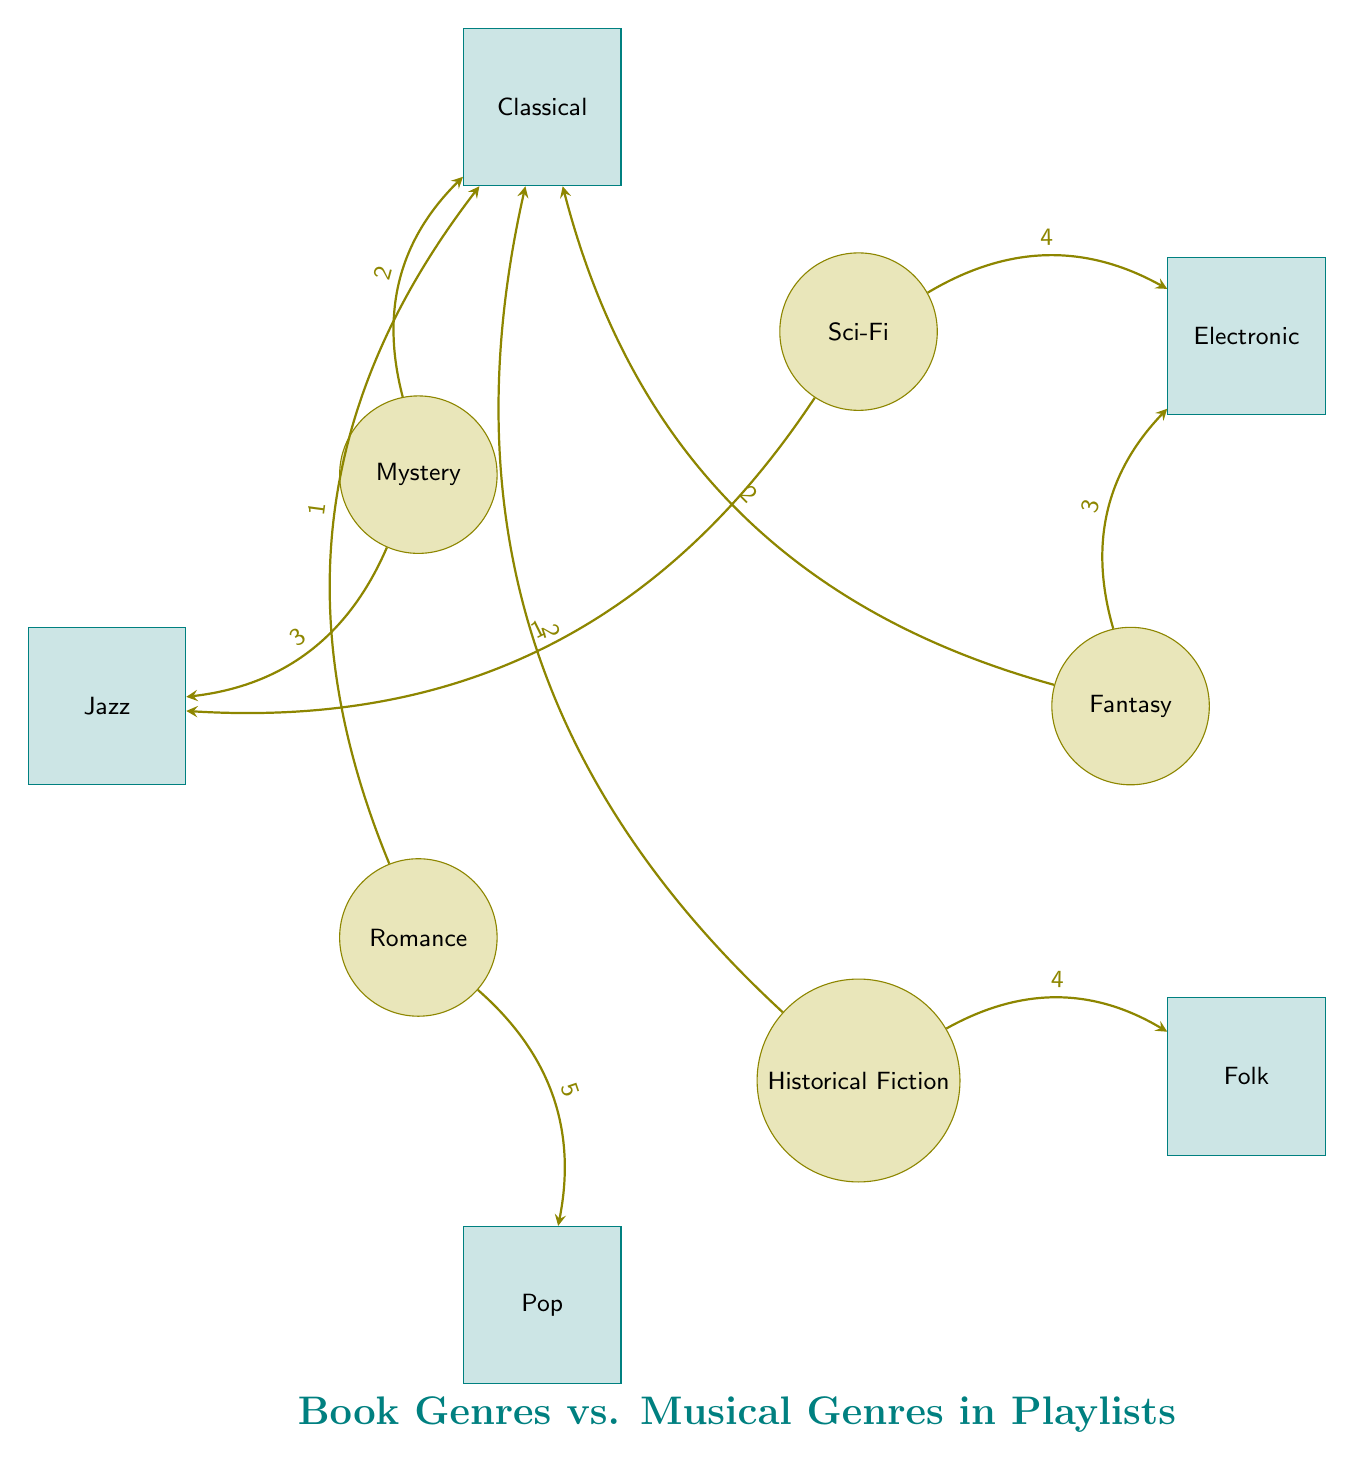What is the value of the link between Fantasy and Electronic? The link between Fantasy and Electronic is represented by an arrow in the diagram, with a value label on it. The label indicates the value is 3.
Answer: 3 Which musical genre is most connected to Romance? The connection from Romance is strongest to Pop, which is shown by the link with the highest value of 5, indicating the number of playlists.
Answer: Pop How many book genres are represented in the diagram? The diagram lists five different book genres as nodes, which can be counted visually. Each genre is distinctly marked, totaling to five.
Answer: 5 Which book genre has the least connections to musical genres? From analyzing the links of each book genre, Romance connects to two musical genres (Pop and Classical), which is less than other genres. Thus, Romance has the least connections compared to others.
Answer: Romance How many total connections are shown in the diagram? By counting each link between book and musical genres, we see a total of 10 links, indicating how many connections are present.
Answer: 10 Which musical genre is most frequently associated with Historical Fiction? Historical Fiction has two connections, but the link with the highest value is with Folk, indicated by the value of 4 attached to it. Therefore, Folk is the most frequently associated musical genre.
Answer: Folk What is the combined value of connections for the Mystery genre? By adding up the values of the connections of Mystery to Jazz and Classical, we calculate (3 + 2), which gives us a total of 5 connections.
Answer: 5 Which book genre connects to both Classical and Electronic? Looking at the nodes, Fantasy connects to both Classical and Electronic, as indicated by the separate links leading from it to those two musical genres.
Answer: Fantasy 